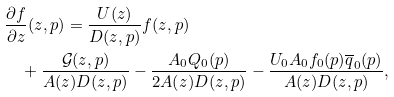Convert formula to latex. <formula><loc_0><loc_0><loc_500><loc_500>& \frac { \partial f } { \partial z } ( z , p ) = \frac { U ( z ) } { D ( z , p ) } f ( z , p ) \\ & \quad + \frac { \mathcal { G } ( z , p ) } { A ( z ) D ( z , p ) } - \frac { A _ { 0 } Q _ { 0 } ( p ) } { 2 A ( z ) D ( z , p ) } - \frac { U _ { 0 } A _ { 0 } f _ { 0 } ( p ) \overline { q } _ { 0 } ( p ) } { A ( z ) D ( z , p ) } ,</formula> 